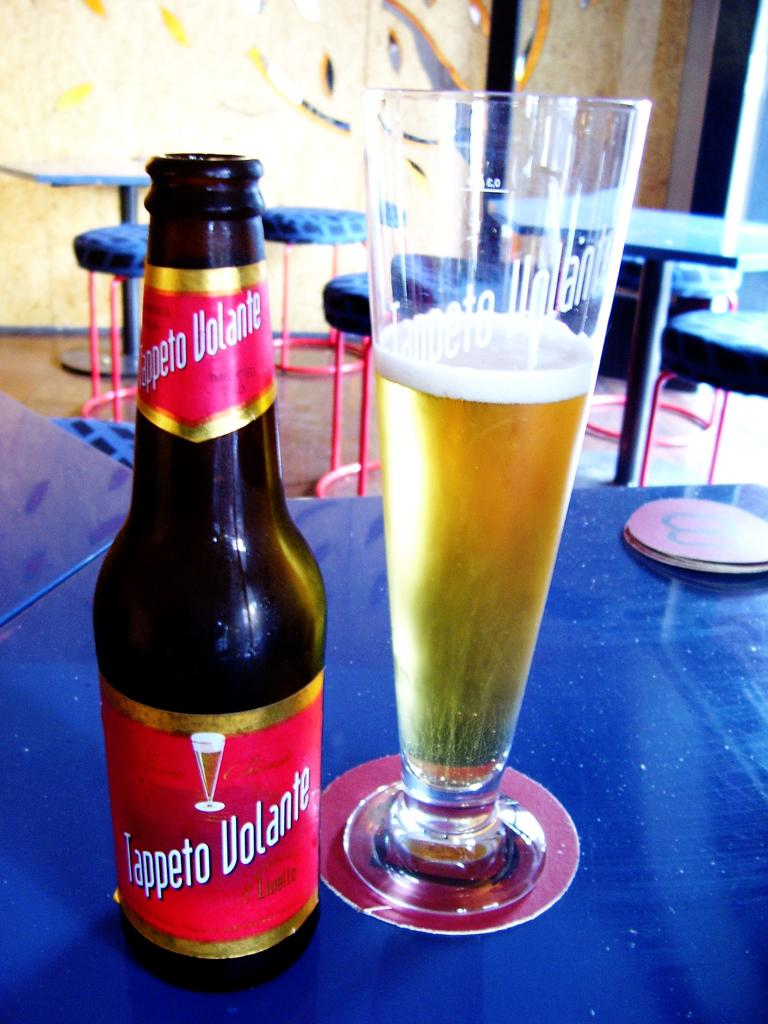What is on the table in the image? There is a wine bottle and a glass filled with wine on the table. What is the glass filled with? The glass is filled with wine. What can be seen in the background of the image? There are chairs and a wall visible in the background of the image. What type of silk is draped over the wine bottle in the image? There is no silk present in the image; it only features a wine bottle and a glass filled with wine on a table. 